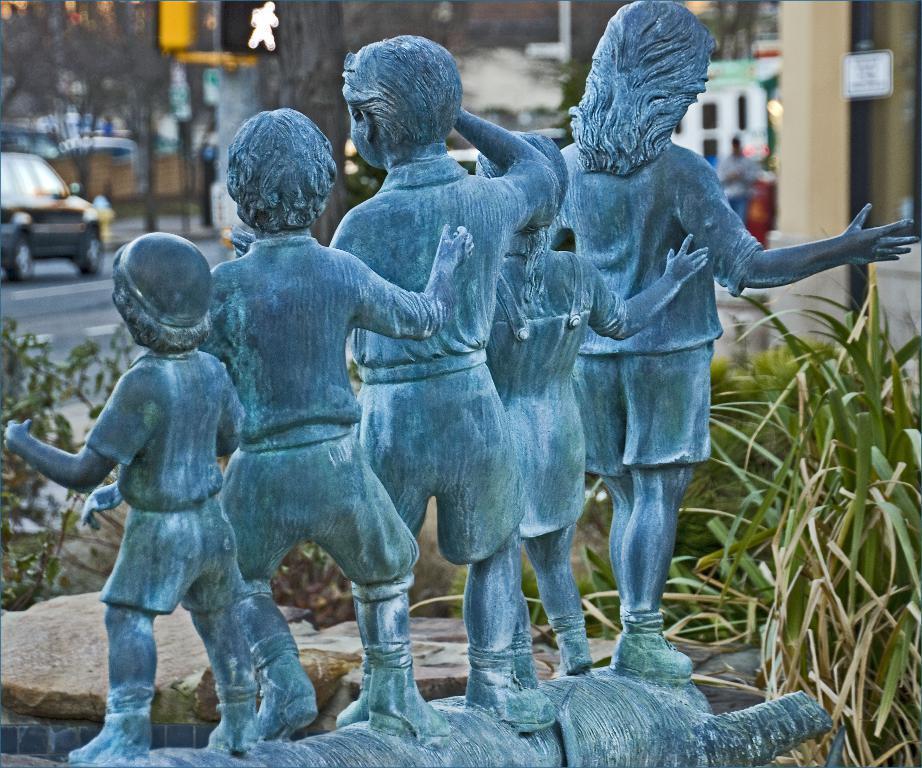Could you give a brief overview of what you see in this image? In this picture we can see a statue, stones, plants and in the background we can see a person, trees, car on the road, some objects and it is blurry. 